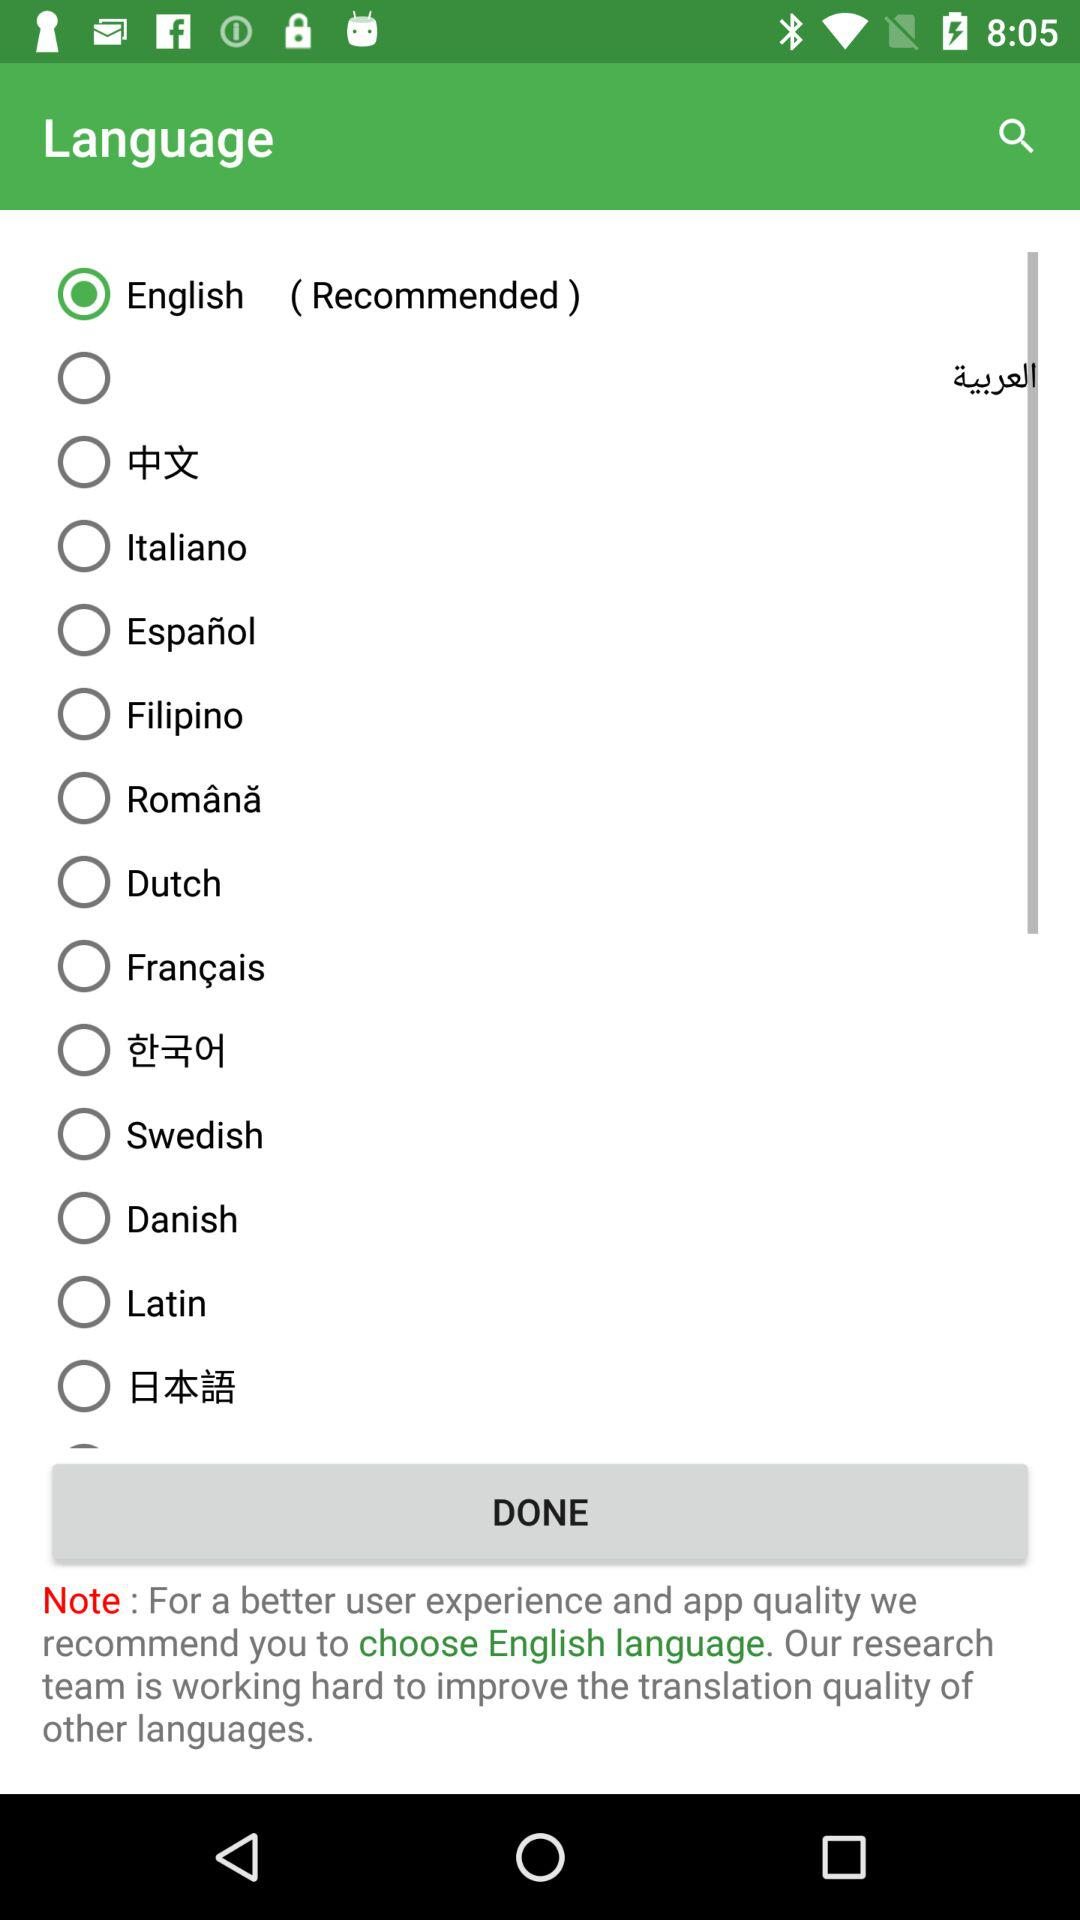Which language is selected? The selected language is "English". 